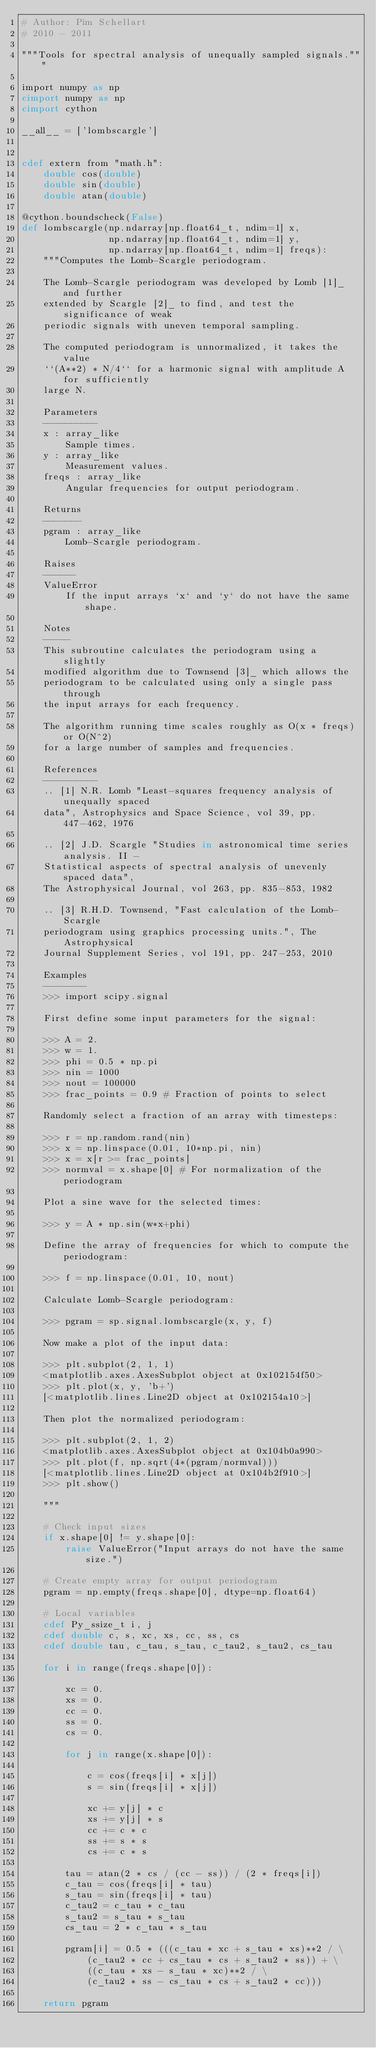Convert code to text. <code><loc_0><loc_0><loc_500><loc_500><_Cython_># Author: Pim Schellart
# 2010 - 2011

"""Tools for spectral analysis of unequally sampled signals."""

import numpy as np
cimport numpy as np
cimport cython

__all__ = ['lombscargle']


cdef extern from "math.h":
    double cos(double)
    double sin(double)
    double atan(double)

@cython.boundscheck(False)
def lombscargle(np.ndarray[np.float64_t, ndim=1] x,
                np.ndarray[np.float64_t, ndim=1] y,
                np.ndarray[np.float64_t, ndim=1] freqs):
    """Computes the Lomb-Scargle periodogram.
    
    The Lomb-Scargle periodogram was developed by Lomb [1]_ and further
    extended by Scargle [2]_ to find, and test the significance of weak
    periodic signals with uneven temporal sampling.

    The computed periodogram is unnormalized, it takes the value
    ``(A**2) * N/4`` for a harmonic signal with amplitude A for sufficiently
    large N.

    Parameters
    ----------
    x : array_like
        Sample times.
    y : array_like
        Measurement values.
    freqs : array_like
        Angular frequencies for output periodogram.

    Returns
    -------
    pgram : array_like
        Lomb-Scargle periodogram.

    Raises
    ------
    ValueError
        If the input arrays `x` and `y` do not have the same shape.

    Notes
    -----
    This subroutine calculates the periodogram using a slightly
    modified algorithm due to Townsend [3]_ which allows the
    periodogram to be calculated using only a single pass through
    the input arrays for each frequency.

    The algorithm running time scales roughly as O(x * freqs) or O(N^2)
    for a large number of samples and frequencies.

    References
    ----------
    .. [1] N.R. Lomb "Least-squares frequency analysis of unequally spaced
    data", Astrophysics and Space Science, vol 39, pp. 447-462, 1976

    .. [2] J.D. Scargle "Studies in astronomical time series analysis. II - 
    Statistical aspects of spectral analysis of unevenly spaced data",
    The Astrophysical Journal, vol 263, pp. 835-853, 1982

    .. [3] R.H.D. Townsend, "Fast calculation of the Lomb-Scargle
    periodogram using graphics processing units.", The Astrophysical
    Journal Supplement Series, vol 191, pp. 247-253, 2010

    Examples
    --------
    >>> import scipy.signal

    First define some input parameters for the signal:

    >>> A = 2.
    >>> w = 1.
    >>> phi = 0.5 * np.pi
    >>> nin = 1000
    >>> nout = 100000
    >>> frac_points = 0.9 # Fraction of points to select
     
    Randomly select a fraction of an array with timesteps:

    >>> r = np.random.rand(nin)
    >>> x = np.linspace(0.01, 10*np.pi, nin)
    >>> x = x[r >= frac_points]
    >>> normval = x.shape[0] # For normalization of the periodogram
     
    Plot a sine wave for the selected times:

    >>> y = A * np.sin(w*x+phi)

    Define the array of frequencies for which to compute the periodogram:
    
    >>> f = np.linspace(0.01, 10, nout)
     
    Calculate Lomb-Scargle periodogram:

    >>> pgram = sp.signal.lombscargle(x, y, f)

    Now make a plot of the input data:

    >>> plt.subplot(2, 1, 1)
    <matplotlib.axes.AxesSubplot object at 0x102154f50>
    >>> plt.plot(x, y, 'b+')
    [<matplotlib.lines.Line2D object at 0x102154a10>]

    Then plot the normalized periodogram:

    >>> plt.subplot(2, 1, 2)
    <matplotlib.axes.AxesSubplot object at 0x104b0a990>
    >>> plt.plot(f, np.sqrt(4*(pgram/normval)))
    [<matplotlib.lines.Line2D object at 0x104b2f910>]
    >>> plt.show()
    
    """

    # Check input sizes
    if x.shape[0] != y.shape[0]:
        raise ValueError("Input arrays do not have the same size.")

    # Create empty array for output periodogram
    pgram = np.empty(freqs.shape[0], dtype=np.float64)

    # Local variables
    cdef Py_ssize_t i, j
    cdef double c, s, xc, xs, cc, ss, cs
    cdef double tau, c_tau, s_tau, c_tau2, s_tau2, cs_tau

    for i in range(freqs.shape[0]):

        xc = 0.
        xs = 0.
        cc = 0.
        ss = 0.
        cs = 0.

        for j in range(x.shape[0]):

            c = cos(freqs[i] * x[j])
            s = sin(freqs[i] * x[j])
            
            xc += y[j] * c
            xs += y[j] * s
            cc += c * c
            ss += s * s
            cs += c * s

        tau = atan(2 * cs / (cc - ss)) / (2 * freqs[i])
        c_tau = cos(freqs[i] * tau)
        s_tau = sin(freqs[i] * tau)
        c_tau2 = c_tau * c_tau
        s_tau2 = s_tau * s_tau
        cs_tau = 2 * c_tau * s_tau

        pgram[i] = 0.5 * (((c_tau * xc + s_tau * xs)**2 / \
            (c_tau2 * cc + cs_tau * cs + s_tau2 * ss)) + \
            ((c_tau * xs - s_tau * xc)**2 / \
            (c_tau2 * ss - cs_tau * cs + s_tau2 * cc)))

    return pgram

</code> 